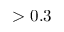<formula> <loc_0><loc_0><loc_500><loc_500>> 0 . 3</formula> 